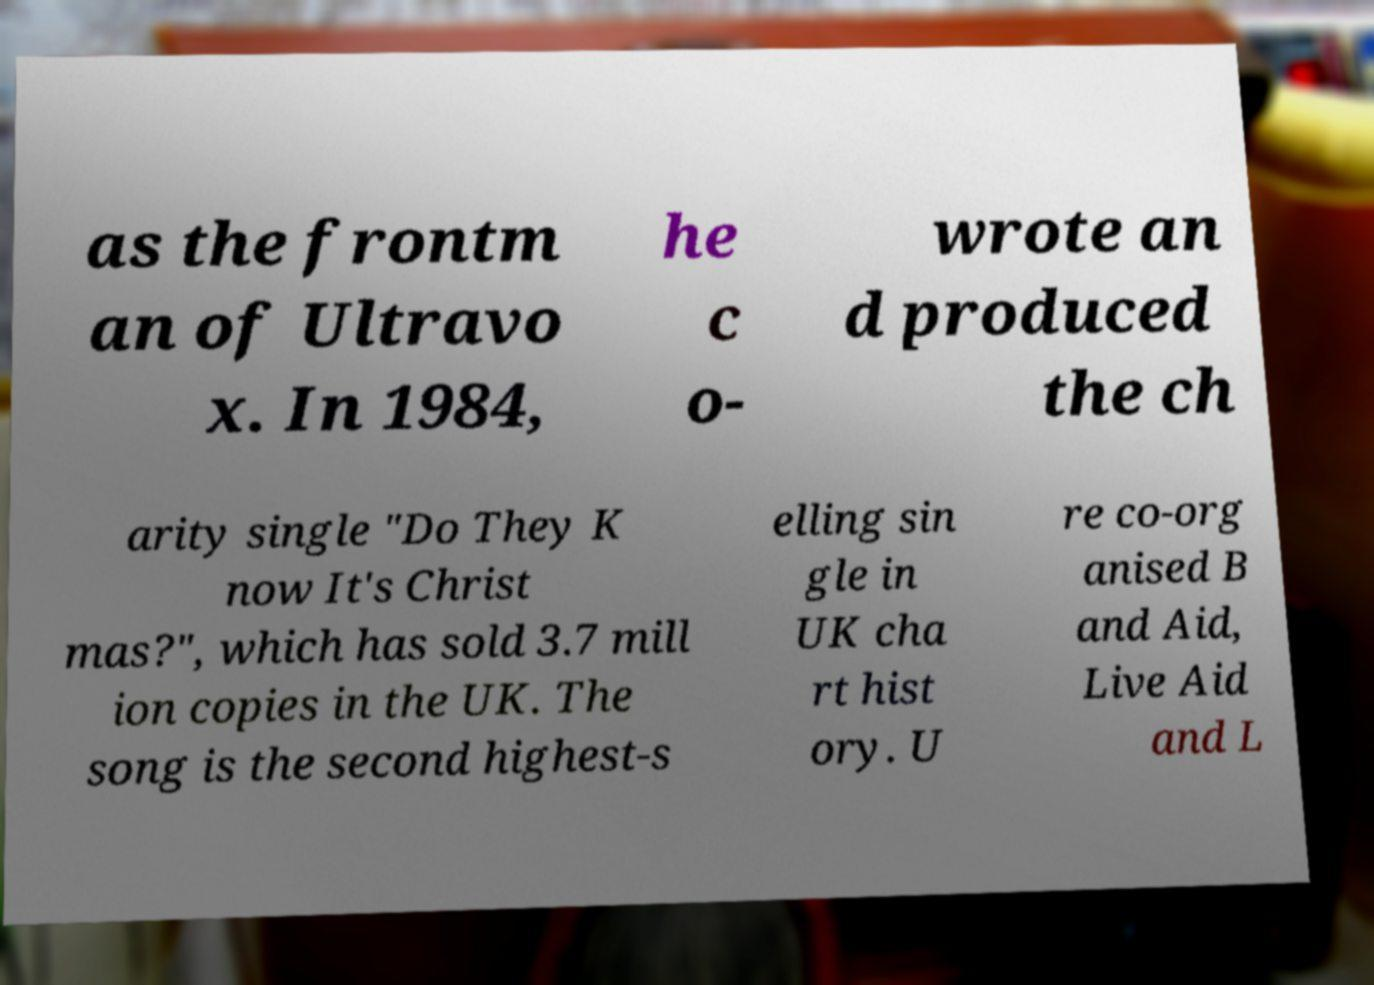Could you assist in decoding the text presented in this image and type it out clearly? as the frontm an of Ultravo x. In 1984, he c o- wrote an d produced the ch arity single "Do They K now It's Christ mas?", which has sold 3.7 mill ion copies in the UK. The song is the second highest-s elling sin gle in UK cha rt hist ory. U re co-org anised B and Aid, Live Aid and L 